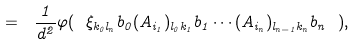<formula> <loc_0><loc_0><loc_500><loc_500>= \ \frac { 1 } { d ^ { 2 } } \varphi ( \ \xi _ { k _ { 0 } l _ { n } } b _ { 0 } ( A _ { i _ { 1 } } ) _ { l _ { 0 } k _ { 1 } } b _ { 1 } \cdots ( A _ { i _ { n } } ) _ { l _ { n - 1 } k _ { n } } b _ { n } \ ) ,</formula> 